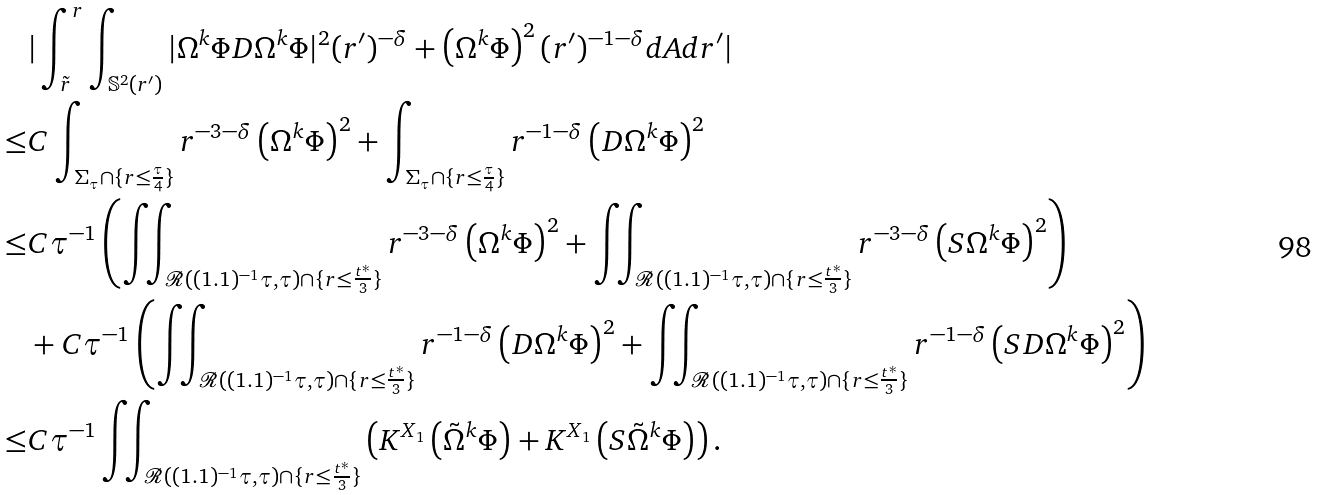<formula> <loc_0><loc_0><loc_500><loc_500>& | \int _ { \tilde { r } } ^ { r } \int _ { \mathbb { S } ^ { 2 } ( r ^ { \prime } ) } | \Omega ^ { k } \Phi D \Omega ^ { k } \Phi | ^ { 2 } ( r ^ { \prime } ) ^ { - \delta } + \left ( \Omega ^ { k } \Phi \right ) ^ { 2 } ( r ^ { \prime } ) ^ { - 1 - \delta } d A d r ^ { \prime } | \\ \leq & C \int _ { \Sigma _ { \tau } \cap \{ r \leq \frac { \tau } { 4 } \} } r ^ { - 3 - \delta } \left ( \Omega ^ { k } \Phi \right ) ^ { 2 } + \int _ { \Sigma _ { \tau } \cap \{ r \leq \frac { \tau } { 4 } \} } r ^ { - 1 - \delta } \left ( D \Omega ^ { k } \Phi \right ) ^ { 2 } \\ \leq & C \tau ^ { - 1 } \left ( \iint _ { \mathcal { R } ( ( 1 . 1 ) ^ { - 1 } \tau , \tau ) \cap \{ r \leq \frac { t ^ { * } } { 3 } \} } r ^ { - 3 - \delta } \left ( \Omega ^ { k } \Phi \right ) ^ { 2 } + \iint _ { \mathcal { R } ( ( 1 . 1 ) ^ { - 1 } \tau , \tau ) \cap \{ r \leq \frac { t ^ { * } } { 3 } \} } r ^ { - 3 - \delta } \left ( S \Omega ^ { k } \Phi \right ) ^ { 2 } \right ) \\ & + C \tau ^ { - 1 } \left ( \iint _ { \mathcal { R } ( ( 1 . 1 ) ^ { - 1 } \tau , \tau ) \cap \{ r \leq \frac { t ^ { * } } { 3 } \} } r ^ { - 1 - \delta } \left ( D \Omega ^ { k } \Phi \right ) ^ { 2 } + \iint _ { \mathcal { R } ( ( 1 . 1 ) ^ { - 1 } \tau , \tau ) \cap \{ r \leq \frac { t ^ { * } } { 3 } \} } r ^ { - 1 - \delta } \left ( S D \Omega ^ { k } \Phi \right ) ^ { 2 } \right ) \\ \leq & C \tau ^ { - 1 } \iint _ { \mathcal { R } ( ( 1 . 1 ) ^ { - 1 } \tau , \tau ) \cap \{ r \leq \frac { t ^ { * } } { 3 } \} } \left ( K ^ { X _ { 1 } } \left ( \tilde { \Omega } ^ { k } \Phi \right ) + K ^ { X _ { 1 } } \left ( S \tilde { \Omega } ^ { k } \Phi \right ) \right ) .</formula> 